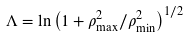<formula> <loc_0><loc_0><loc_500><loc_500>\Lambda = \ln \left ( 1 + \rho _ { \max } ^ { 2 } / \rho _ { \min } ^ { 2 } \right ) ^ { 1 / 2 } \,</formula> 